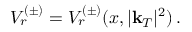<formula> <loc_0><loc_0><loc_500><loc_500>V _ { r } ^ { ( \pm ) } = V _ { r } ^ { ( \pm ) } ( x , | k _ { T } | ^ { 2 } ) \, .</formula> 